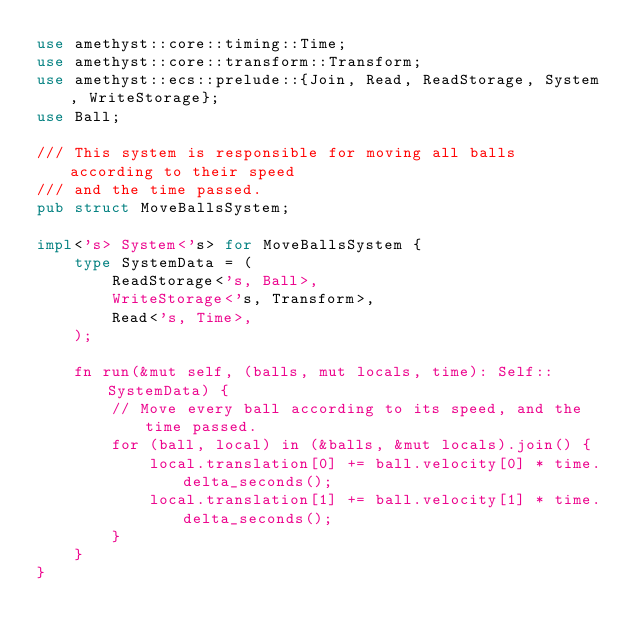Convert code to text. <code><loc_0><loc_0><loc_500><loc_500><_Rust_>use amethyst::core::timing::Time;
use amethyst::core::transform::Transform;
use amethyst::ecs::prelude::{Join, Read, ReadStorage, System, WriteStorage};
use Ball;

/// This system is responsible for moving all balls according to their speed
/// and the time passed.
pub struct MoveBallsSystem;

impl<'s> System<'s> for MoveBallsSystem {
    type SystemData = (
        ReadStorage<'s, Ball>,
        WriteStorage<'s, Transform>,
        Read<'s, Time>,
    );

    fn run(&mut self, (balls, mut locals, time): Self::SystemData) {
        // Move every ball according to its speed, and the time passed.
        for (ball, local) in (&balls, &mut locals).join() {
            local.translation[0] += ball.velocity[0] * time.delta_seconds();
            local.translation[1] += ball.velocity[1] * time.delta_seconds();
        }
    }
}
</code> 